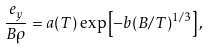Convert formula to latex. <formula><loc_0><loc_0><loc_500><loc_500>\frac { e _ { y } } { B \rho } = a ( T ) \exp \left [ - b ( B / T ) ^ { 1 / 3 } \right ] ,</formula> 